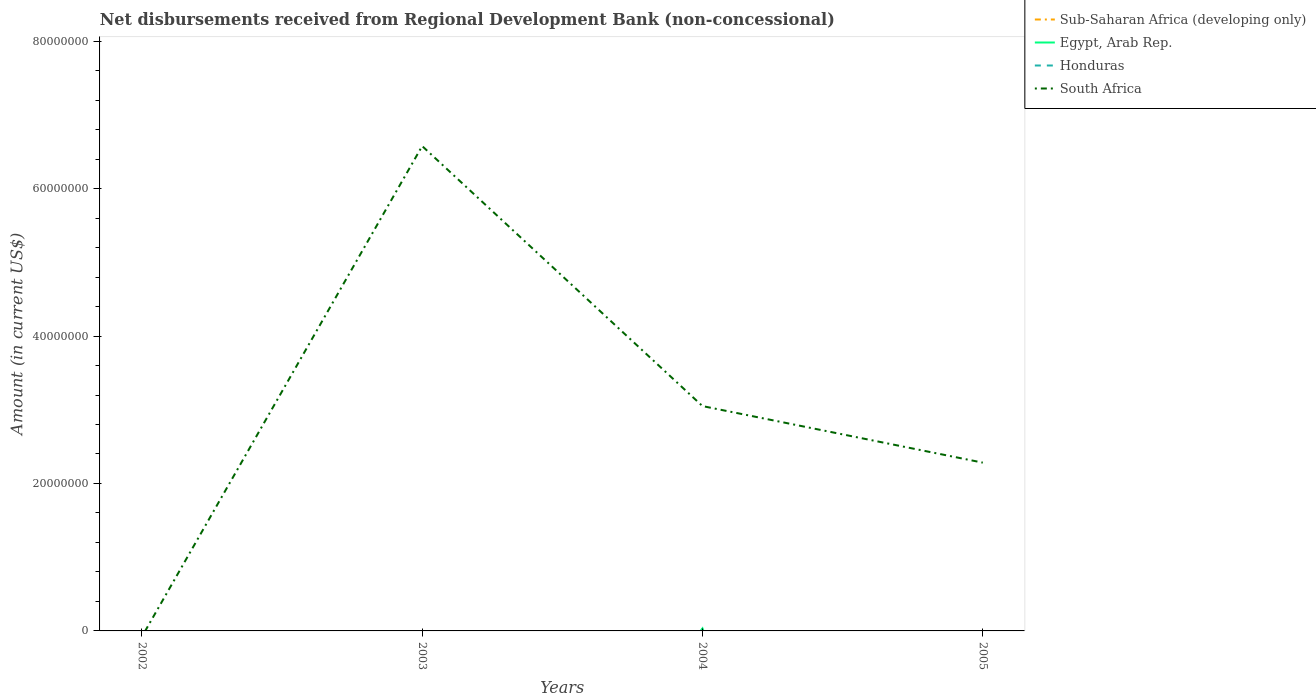Does the line corresponding to South Africa intersect with the line corresponding to Honduras?
Give a very brief answer. No. What is the difference between the highest and the second highest amount of disbursements received from Regional Development Bank in Egypt, Arab Rep.?
Your response must be concise. 3.41e+05. What is the difference between the highest and the lowest amount of disbursements received from Regional Development Bank in Egypt, Arab Rep.?
Keep it short and to the point. 1. How many years are there in the graph?
Offer a terse response. 4. What is the difference between two consecutive major ticks on the Y-axis?
Your answer should be very brief. 2.00e+07. Are the values on the major ticks of Y-axis written in scientific E-notation?
Provide a succinct answer. No. Does the graph contain grids?
Give a very brief answer. No. How are the legend labels stacked?
Make the answer very short. Vertical. What is the title of the graph?
Your answer should be very brief. Net disbursements received from Regional Development Bank (non-concessional). Does "Middle East & North Africa (all income levels)" appear as one of the legend labels in the graph?
Offer a terse response. No. What is the Amount (in current US$) of Honduras in 2003?
Your response must be concise. 0. What is the Amount (in current US$) of South Africa in 2003?
Your answer should be compact. 6.58e+07. What is the Amount (in current US$) of Sub-Saharan Africa (developing only) in 2004?
Make the answer very short. 0. What is the Amount (in current US$) of Egypt, Arab Rep. in 2004?
Offer a terse response. 3.41e+05. What is the Amount (in current US$) of Honduras in 2004?
Your response must be concise. 0. What is the Amount (in current US$) of South Africa in 2004?
Offer a very short reply. 3.05e+07. What is the Amount (in current US$) in Honduras in 2005?
Offer a very short reply. 0. What is the Amount (in current US$) of South Africa in 2005?
Ensure brevity in your answer.  2.28e+07. Across all years, what is the maximum Amount (in current US$) in Egypt, Arab Rep.?
Make the answer very short. 3.41e+05. Across all years, what is the maximum Amount (in current US$) of South Africa?
Give a very brief answer. 6.58e+07. Across all years, what is the minimum Amount (in current US$) of Egypt, Arab Rep.?
Give a very brief answer. 0. Across all years, what is the minimum Amount (in current US$) of South Africa?
Provide a short and direct response. 0. What is the total Amount (in current US$) in Sub-Saharan Africa (developing only) in the graph?
Your response must be concise. 0. What is the total Amount (in current US$) of Egypt, Arab Rep. in the graph?
Provide a short and direct response. 3.41e+05. What is the total Amount (in current US$) of South Africa in the graph?
Ensure brevity in your answer.  1.19e+08. What is the difference between the Amount (in current US$) of South Africa in 2003 and that in 2004?
Offer a terse response. 3.53e+07. What is the difference between the Amount (in current US$) of South Africa in 2003 and that in 2005?
Offer a very short reply. 4.29e+07. What is the difference between the Amount (in current US$) of South Africa in 2004 and that in 2005?
Keep it short and to the point. 7.67e+06. What is the difference between the Amount (in current US$) in Egypt, Arab Rep. in 2004 and the Amount (in current US$) in South Africa in 2005?
Ensure brevity in your answer.  -2.25e+07. What is the average Amount (in current US$) in Sub-Saharan Africa (developing only) per year?
Offer a terse response. 0. What is the average Amount (in current US$) of Egypt, Arab Rep. per year?
Keep it short and to the point. 8.52e+04. What is the average Amount (in current US$) in South Africa per year?
Offer a terse response. 2.98e+07. In the year 2004, what is the difference between the Amount (in current US$) of Egypt, Arab Rep. and Amount (in current US$) of South Africa?
Give a very brief answer. -3.02e+07. What is the ratio of the Amount (in current US$) in South Africa in 2003 to that in 2004?
Your response must be concise. 2.16. What is the ratio of the Amount (in current US$) in South Africa in 2003 to that in 2005?
Make the answer very short. 2.88. What is the ratio of the Amount (in current US$) of South Africa in 2004 to that in 2005?
Provide a short and direct response. 1.34. What is the difference between the highest and the second highest Amount (in current US$) of South Africa?
Ensure brevity in your answer.  3.53e+07. What is the difference between the highest and the lowest Amount (in current US$) in Egypt, Arab Rep.?
Your response must be concise. 3.41e+05. What is the difference between the highest and the lowest Amount (in current US$) of South Africa?
Offer a very short reply. 6.58e+07. 